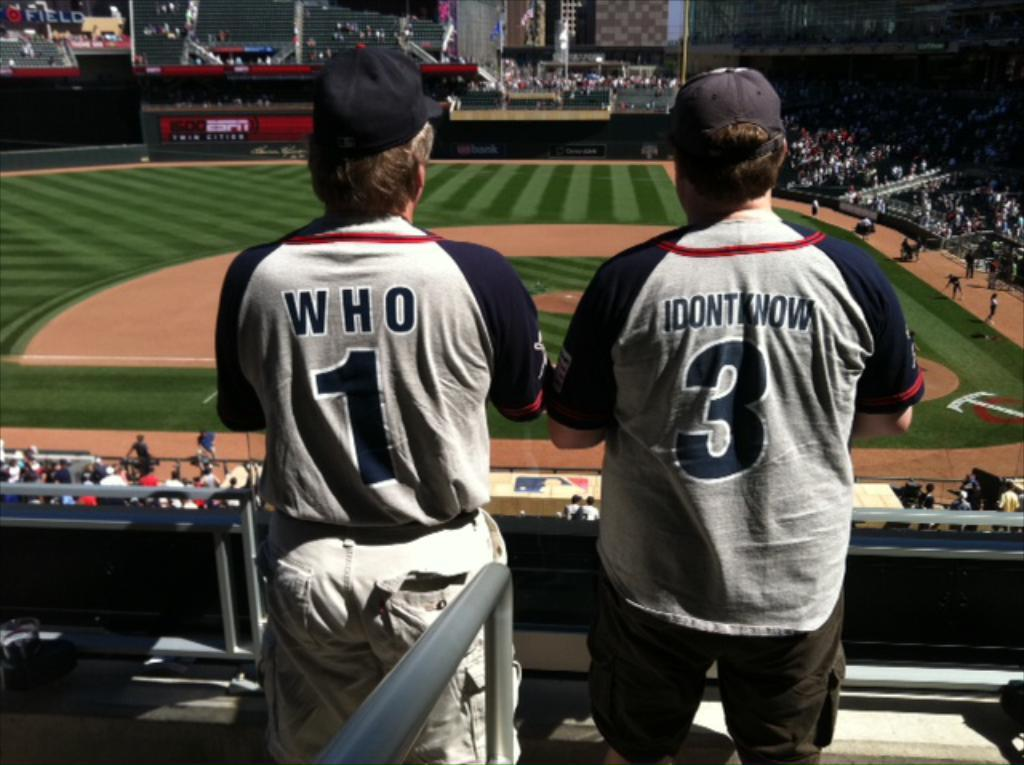<image>
Share a concise interpretation of the image provided. Two fans with named Who and Idontknow watch a ball game. 